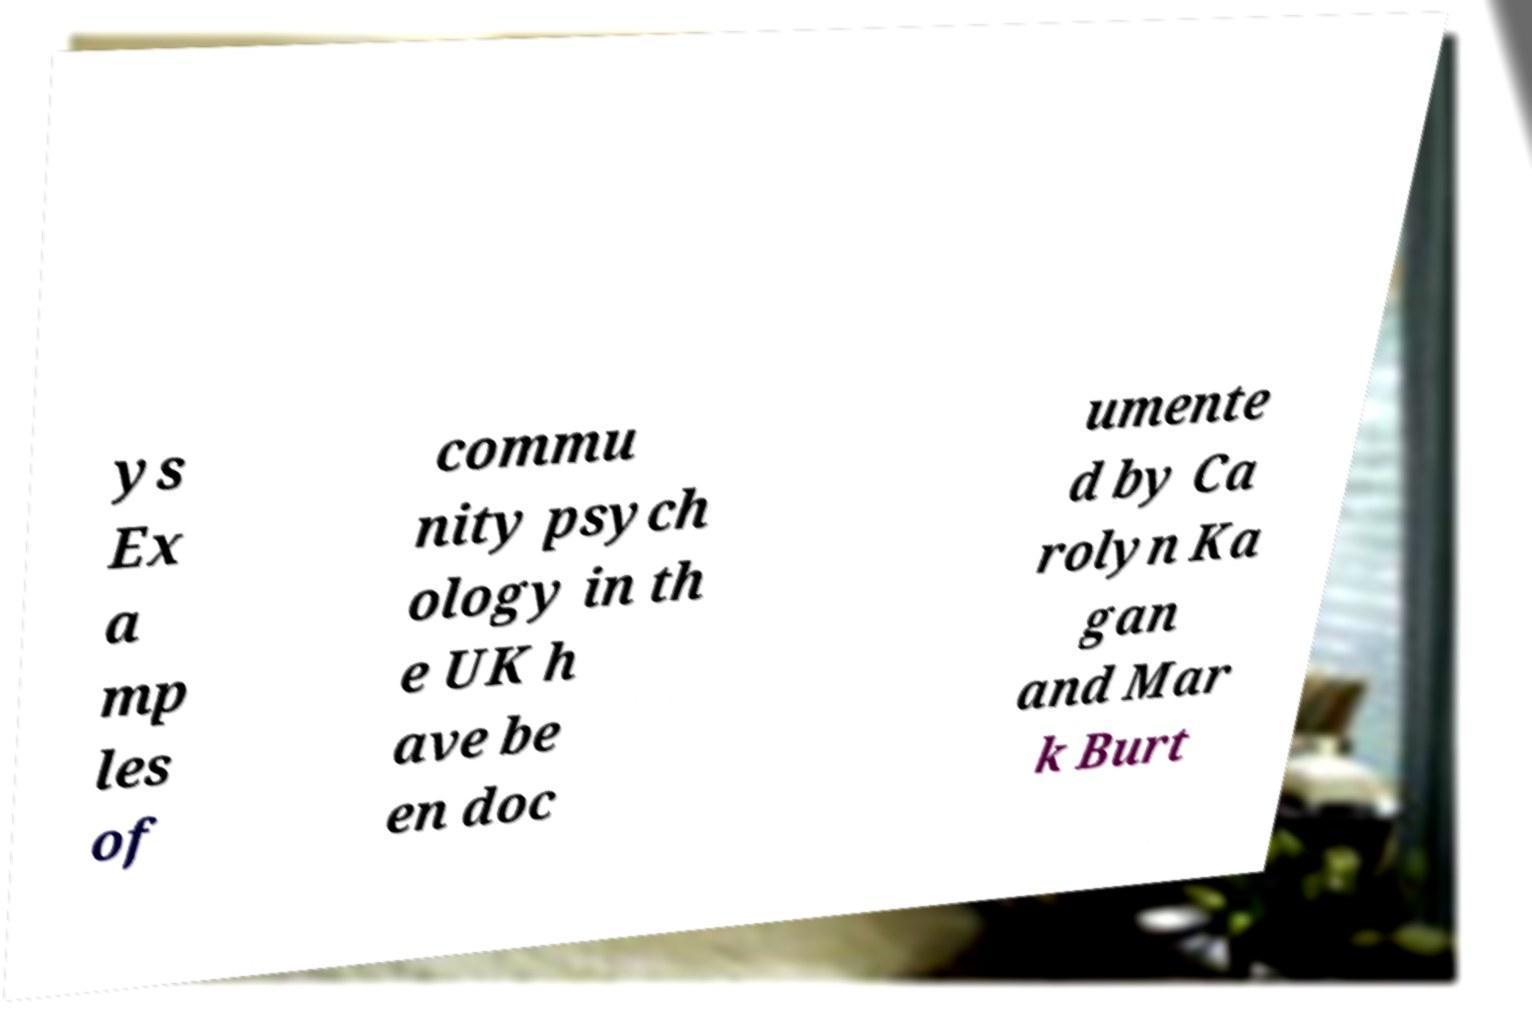Could you extract and type out the text from this image? ys Ex a mp les of commu nity psych ology in th e UK h ave be en doc umente d by Ca rolyn Ka gan and Mar k Burt 